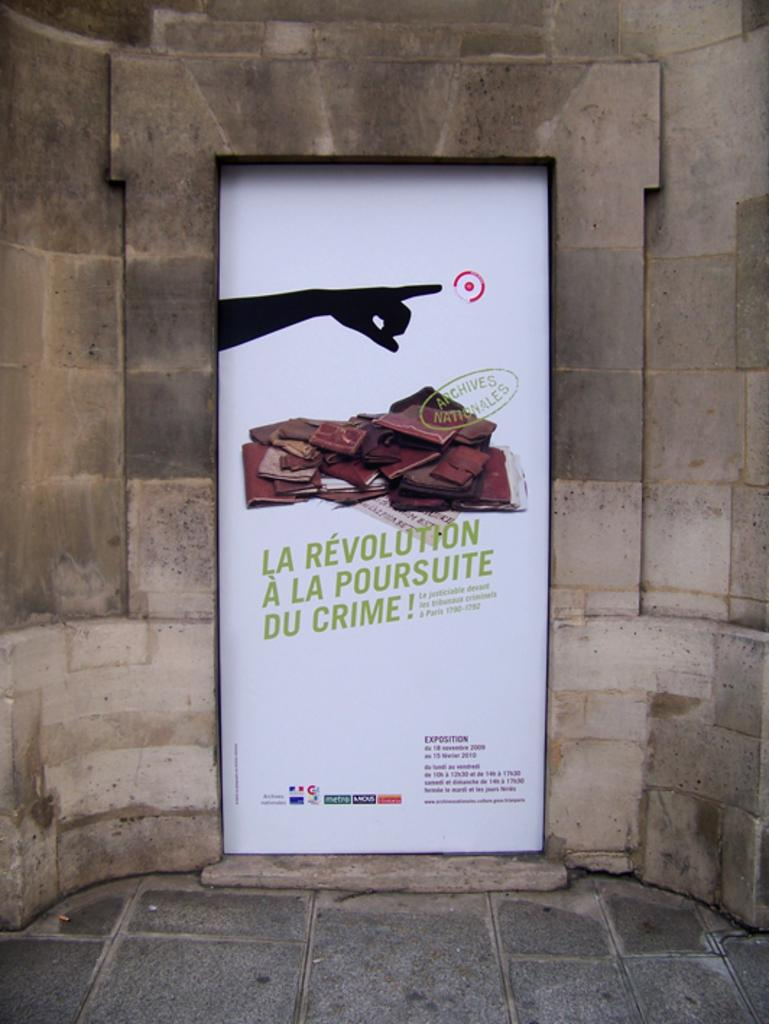Provide a one-sentence caption for the provided image. Advertisement with a finger pointing and says "La Revolution A La Poursuite Du Crime!". 